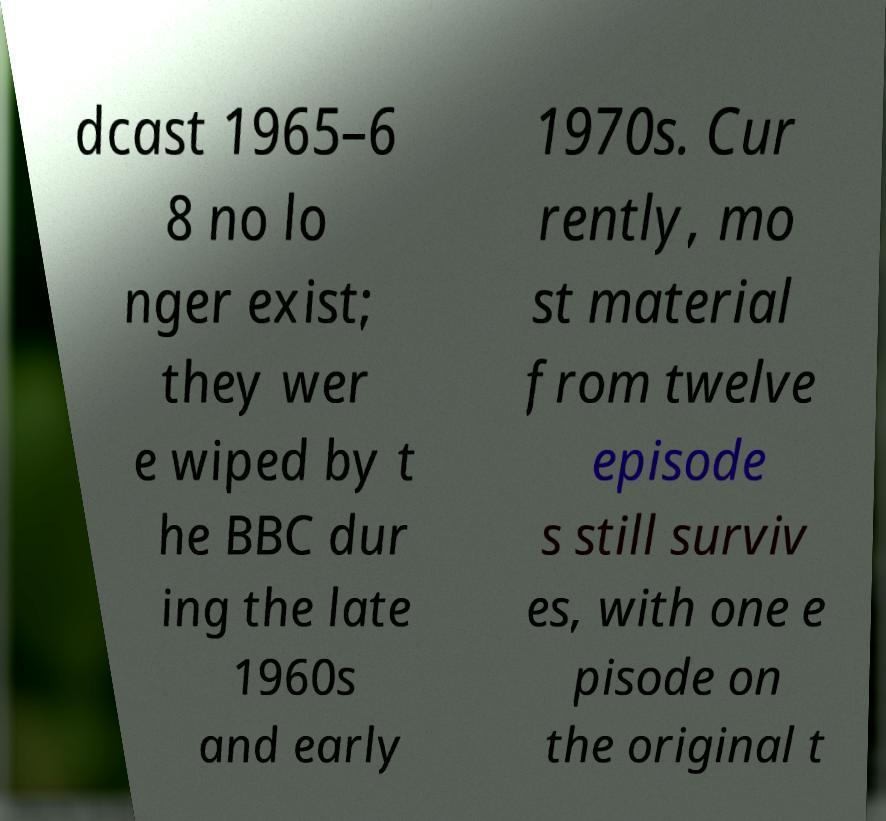Can you accurately transcribe the text from the provided image for me? dcast 1965–6 8 no lo nger exist; they wer e wiped by t he BBC dur ing the late 1960s and early 1970s. Cur rently, mo st material from twelve episode s still surviv es, with one e pisode on the original t 